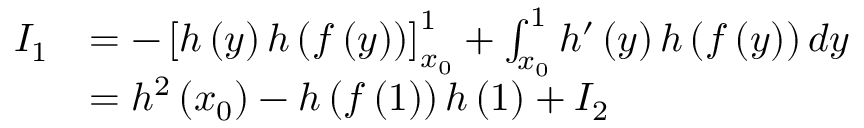Convert formula to latex. <formula><loc_0><loc_0><loc_500><loc_500>\begin{array} { r l } { I _ { 1 } } & { = - \left [ h \left ( y \right ) h \left ( f \left ( y \right ) \right ) \right ] _ { x _ { 0 } } ^ { 1 } + \int _ { x _ { 0 } } ^ { 1 } h ^ { \prime } \left ( y \right ) h \left ( f \left ( y \right ) \right ) d y } \\ & { = h ^ { 2 } \left ( x _ { 0 } \right ) - h \left ( f \left ( 1 \right ) \right ) h \left ( 1 \right ) + I _ { 2 } } \end{array}</formula> 